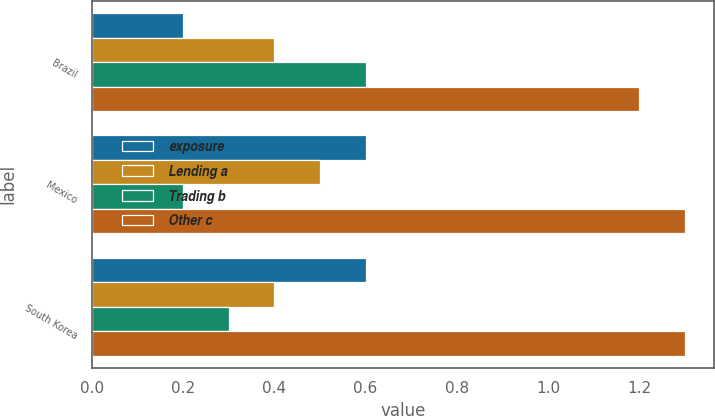Convert chart to OTSL. <chart><loc_0><loc_0><loc_500><loc_500><stacked_bar_chart><ecel><fcel>Brazil<fcel>Mexico<fcel>South Korea<nl><fcel>exposure<fcel>0.2<fcel>0.6<fcel>0.6<nl><fcel>Lending a<fcel>0.4<fcel>0.5<fcel>0.4<nl><fcel>Trading b<fcel>0.6<fcel>0.2<fcel>0.3<nl><fcel>Other c<fcel>1.2<fcel>1.3<fcel>1.3<nl></chart> 